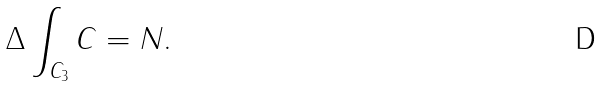Convert formula to latex. <formula><loc_0><loc_0><loc_500><loc_500>\Delta \int _ { C _ { 3 } } C = N .</formula> 